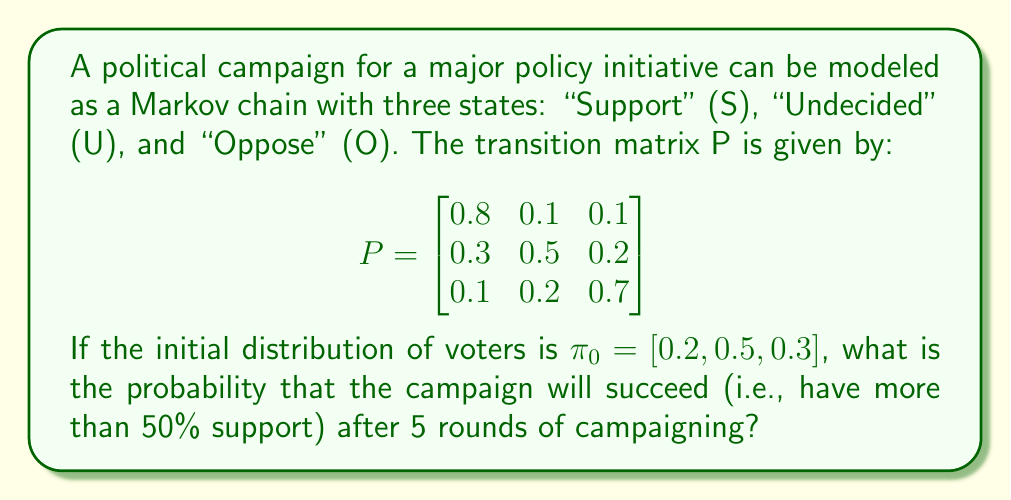Teach me how to tackle this problem. To solve this problem, we'll follow these steps:

1) First, we need to calculate $\pi_5 = \pi_0 P^5$. This gives us the distribution of voters after 5 rounds of campaigning.

2) To calculate $P^5$, we'll use the power method:

   $P^2 = P \cdot P$
   $P^3 = P^2 \cdot P$
   $P^4 = P^3 \cdot P$
   $P^5 = P^4 \cdot P$

3) After calculation, we get:

   $$P^5 \approx \begin{bmatrix}
   0.5385 & 0.2308 & 0.2308 \\
   0.5385 & 0.2308 & 0.2308 \\
   0.5385 & 0.2308 & 0.2308
   \end{bmatrix}$$

4) Now, we can calculate $\pi_5$:

   $\pi_5 = \pi_0 P^5 = [0.2, 0.5, 0.3] \cdot P^5$

   $\pi_5 \approx [0.5385, 0.2308, 0.2308]$

5) The probability of success is the probability of being in the "Support" state, which is the first element of $\pi_5$:

   $P(\text{Success}) \approx 0.5385 = 53.85\%$

6) Since 53.85% > 50%, the campaign has a probability of success greater than 50% after 5 rounds.
Answer: $0.5385$ or $53.85\%$ 